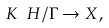Convert formula to latex. <formula><loc_0><loc_0><loc_500><loc_500>K \ H / \Gamma \rightarrow X ,</formula> 